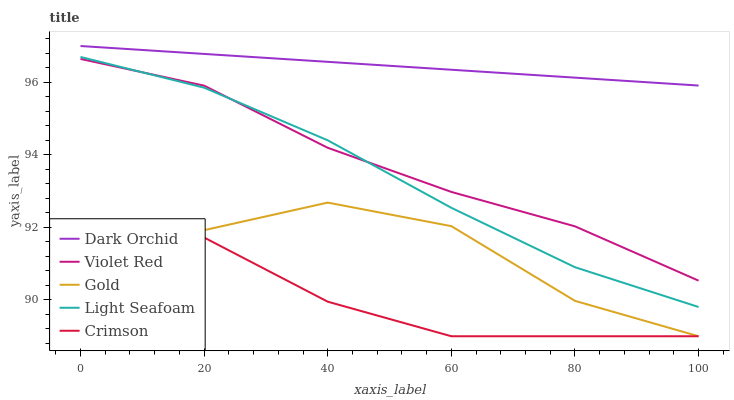Does Crimson have the minimum area under the curve?
Answer yes or no. Yes. Does Dark Orchid have the maximum area under the curve?
Answer yes or no. Yes. Does Violet Red have the minimum area under the curve?
Answer yes or no. No. Does Violet Red have the maximum area under the curve?
Answer yes or no. No. Is Dark Orchid the smoothest?
Answer yes or no. Yes. Is Gold the roughest?
Answer yes or no. Yes. Is Violet Red the smoothest?
Answer yes or no. No. Is Violet Red the roughest?
Answer yes or no. No. Does Crimson have the lowest value?
Answer yes or no. Yes. Does Violet Red have the lowest value?
Answer yes or no. No. Does Dark Orchid have the highest value?
Answer yes or no. Yes. Does Violet Red have the highest value?
Answer yes or no. No. Is Violet Red less than Dark Orchid?
Answer yes or no. Yes. Is Dark Orchid greater than Light Seafoam?
Answer yes or no. Yes. Does Gold intersect Crimson?
Answer yes or no. Yes. Is Gold less than Crimson?
Answer yes or no. No. Is Gold greater than Crimson?
Answer yes or no. No. Does Violet Red intersect Dark Orchid?
Answer yes or no. No. 